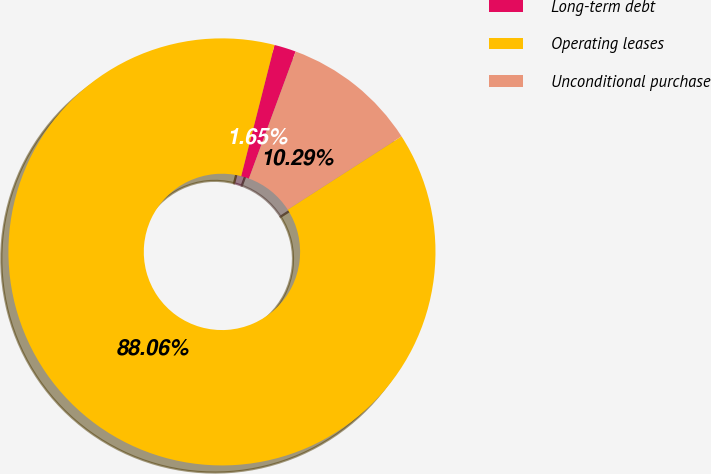Convert chart. <chart><loc_0><loc_0><loc_500><loc_500><pie_chart><fcel>Long-term debt<fcel>Operating leases<fcel>Unconditional purchase<nl><fcel>1.65%<fcel>88.06%<fcel>10.29%<nl></chart> 